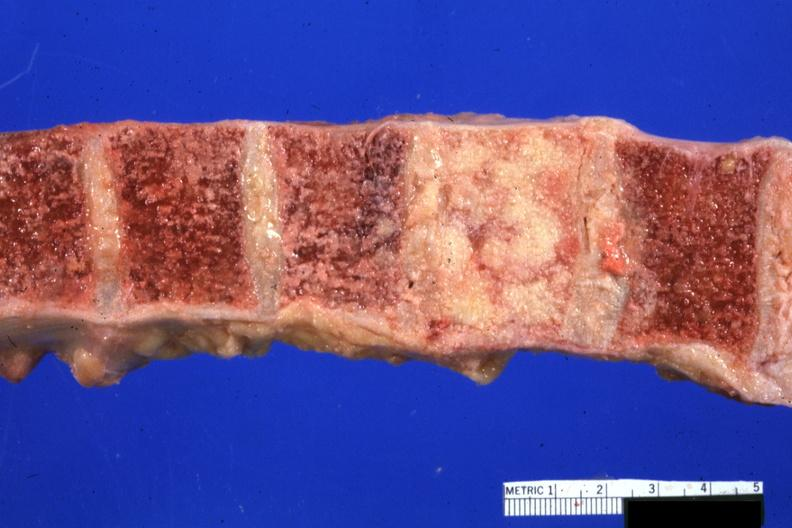what is present?
Answer the question using a single word or phrase. Joints 